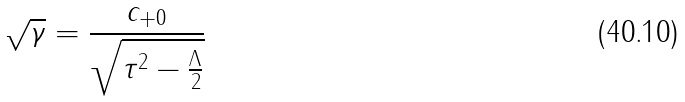<formula> <loc_0><loc_0><loc_500><loc_500>\sqrt { \gamma } = \frac { c _ { + 0 } } { \sqrt { \tau ^ { 2 } - \frac { \Lambda } { 2 } } }</formula> 